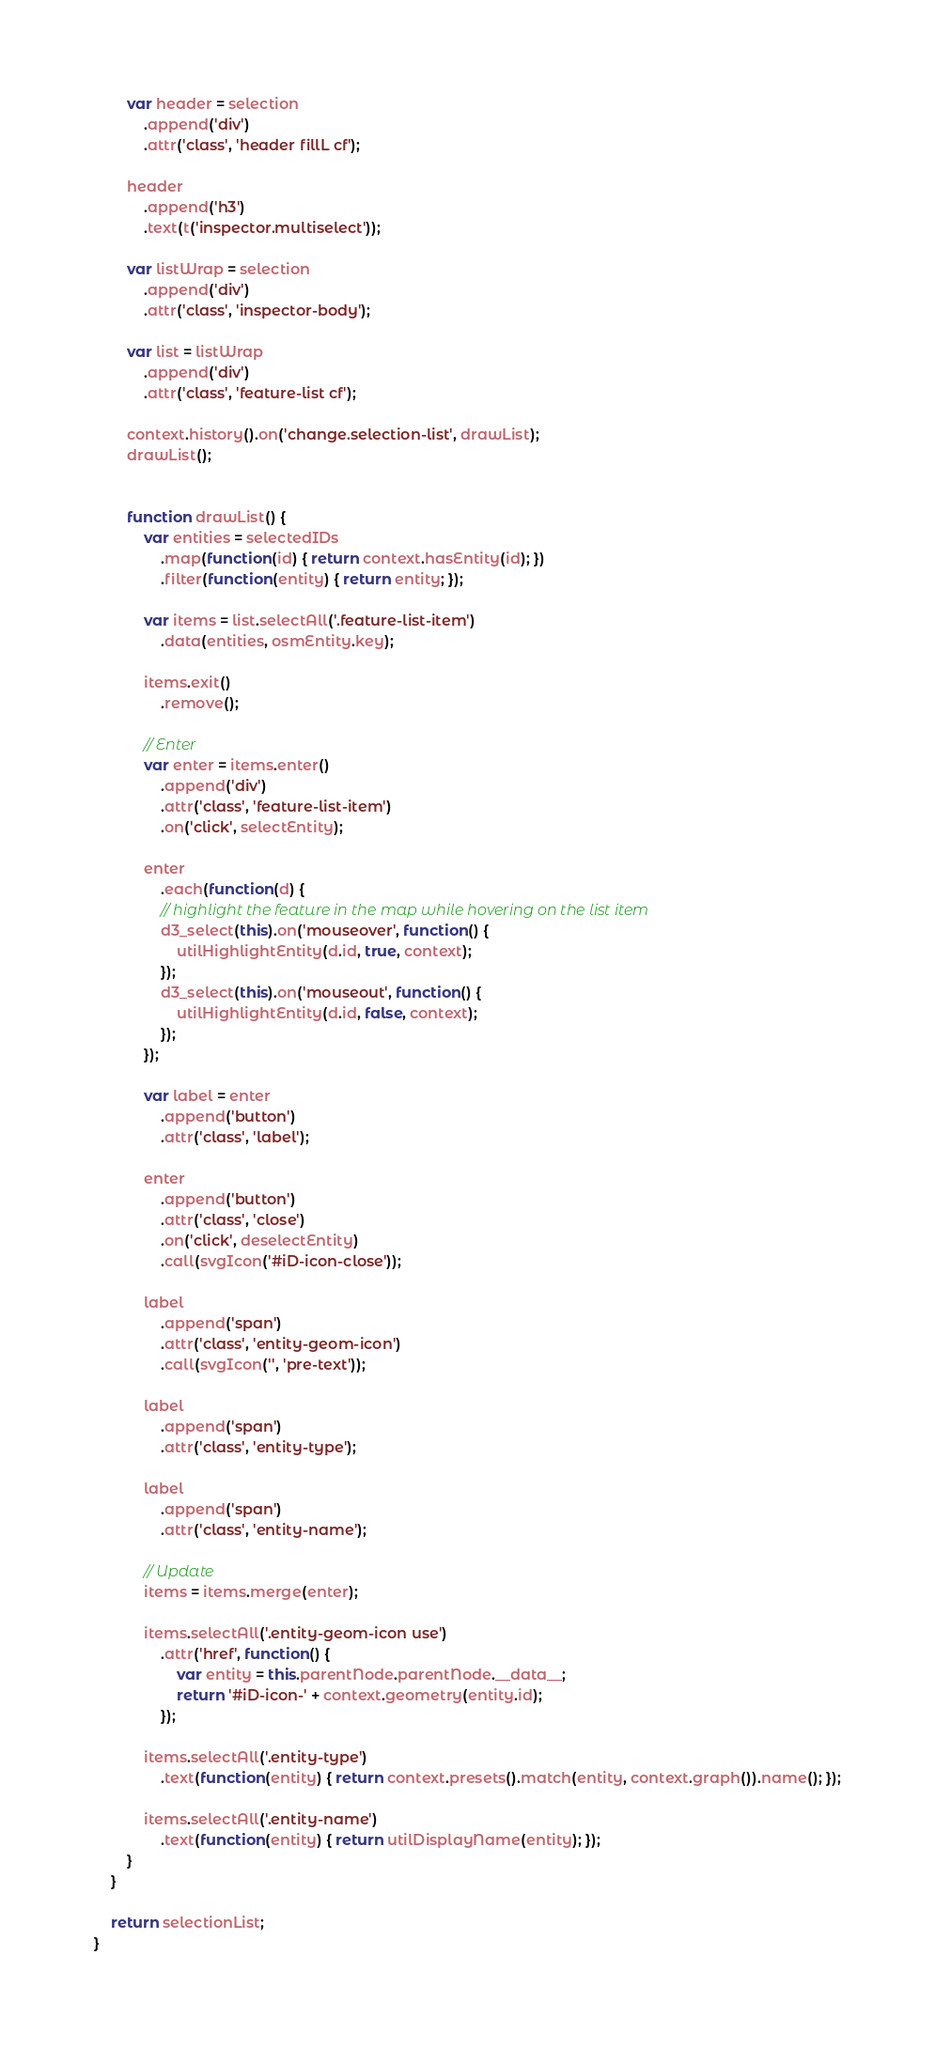Convert code to text. <code><loc_0><loc_0><loc_500><loc_500><_JavaScript_>        var header = selection
            .append('div')
            .attr('class', 'header fillL cf');

        header
            .append('h3')
            .text(t('inspector.multiselect'));

        var listWrap = selection
            .append('div')
            .attr('class', 'inspector-body');

        var list = listWrap
            .append('div')
            .attr('class', 'feature-list cf');

        context.history().on('change.selection-list', drawList);
        drawList();


        function drawList() {
            var entities = selectedIDs
                .map(function(id) { return context.hasEntity(id); })
                .filter(function(entity) { return entity; });

            var items = list.selectAll('.feature-list-item')
                .data(entities, osmEntity.key);

            items.exit()
                .remove();

            // Enter
            var enter = items.enter()
                .append('div')
                .attr('class', 'feature-list-item')
                .on('click', selectEntity);

            enter
                .each(function(d) {
                // highlight the feature in the map while hovering on the list item
                d3_select(this).on('mouseover', function() {
                    utilHighlightEntity(d.id, true, context);
                });
                d3_select(this).on('mouseout', function() {
                    utilHighlightEntity(d.id, false, context);
                });
            });

            var label = enter
                .append('button')
                .attr('class', 'label');

            enter
                .append('button')
                .attr('class', 'close')
                .on('click', deselectEntity)
                .call(svgIcon('#iD-icon-close'));

            label
                .append('span')
                .attr('class', 'entity-geom-icon')
                .call(svgIcon('', 'pre-text'));

            label
                .append('span')
                .attr('class', 'entity-type');

            label
                .append('span')
                .attr('class', 'entity-name');

            // Update
            items = items.merge(enter);

            items.selectAll('.entity-geom-icon use')
                .attr('href', function() {
                    var entity = this.parentNode.parentNode.__data__;
                    return '#iD-icon-' + context.geometry(entity.id);
                });

            items.selectAll('.entity-type')
                .text(function(entity) { return context.presets().match(entity, context.graph()).name(); });

            items.selectAll('.entity-name')
                .text(function(entity) { return utilDisplayName(entity); });
        }
    }

    return selectionList;
}
</code> 